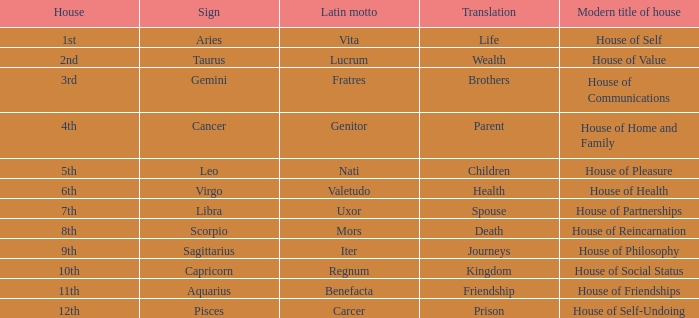What astrological sign is represented by the latin phrase "vita"? Aries. 